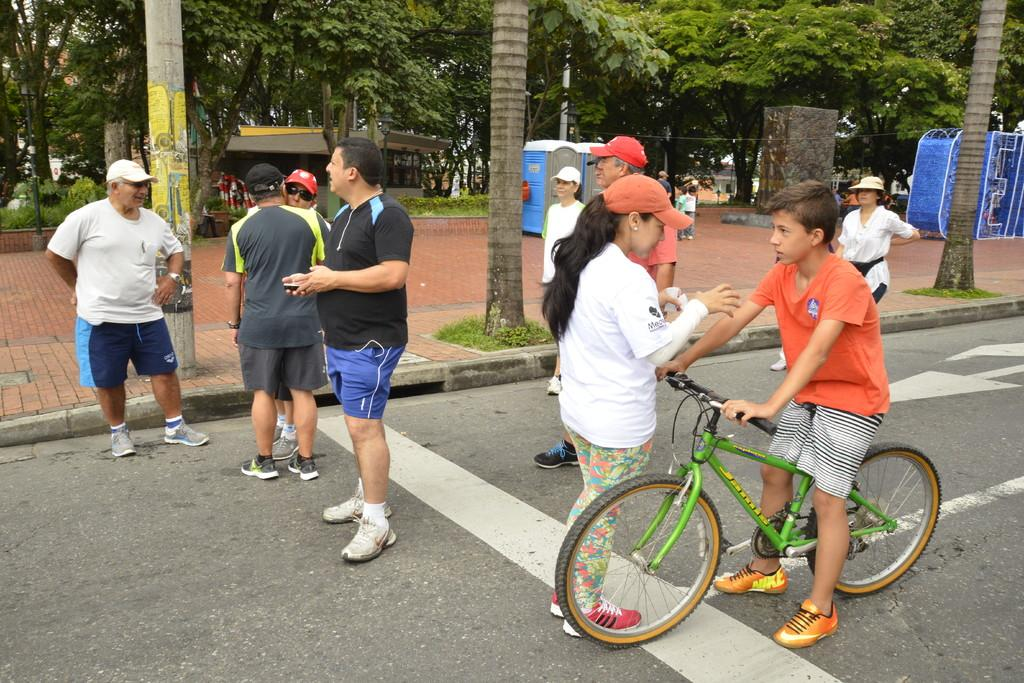What is the child doing in the image? The child is sitting on a bicycle in the image. What else can be seen in the image besides the child on the bicycle? There are people standing on the road in the image. What can be seen in the distance in the image? There are trees visible in the background of the image. What type of goat can be seen sitting next to the child on the bicycle? There is no goat present in the image; it only features a child sitting on a bicycle and people standing on the road. 